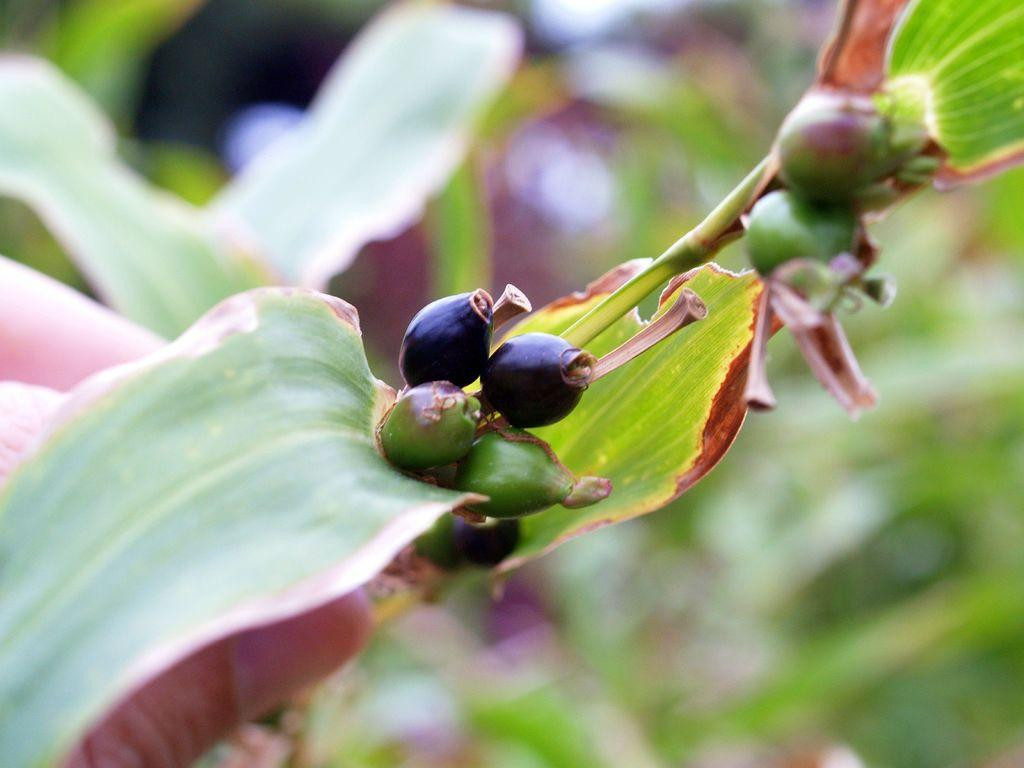What type of plant structures can be seen in the image? There are a few buds and leaves in the image. Can you describe the stage of growth for the plant structures in the image? The presence of buds suggests that the plant is in the process of growing and blooming. What type of vein is visible in the image? There is no vein present in the image; it features plant structures like buds and leaves. Can you tell me how many agreements were made in the image? There is no reference to any agreements in the image, as it features plant structures like buds and leaves. 